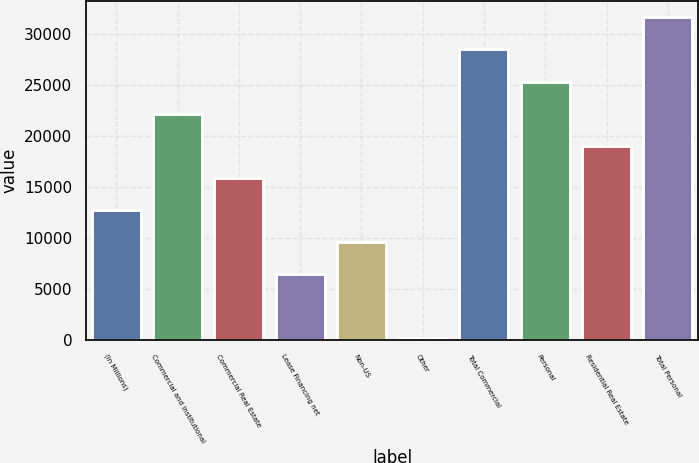<chart> <loc_0><loc_0><loc_500><loc_500><bar_chart><fcel>(In Millions)<fcel>Commercial and Institutional<fcel>Commercial Real Estate<fcel>Lease Financing net<fcel>Non-US<fcel>Other<fcel>Total Commercial<fcel>Personal<fcel>Residential Real Estate<fcel>Total Personal<nl><fcel>12771<fcel>22205.6<fcel>15915.9<fcel>6481.24<fcel>9626.11<fcel>191.5<fcel>28495.3<fcel>25350.5<fcel>19060.7<fcel>31640.2<nl></chart> 